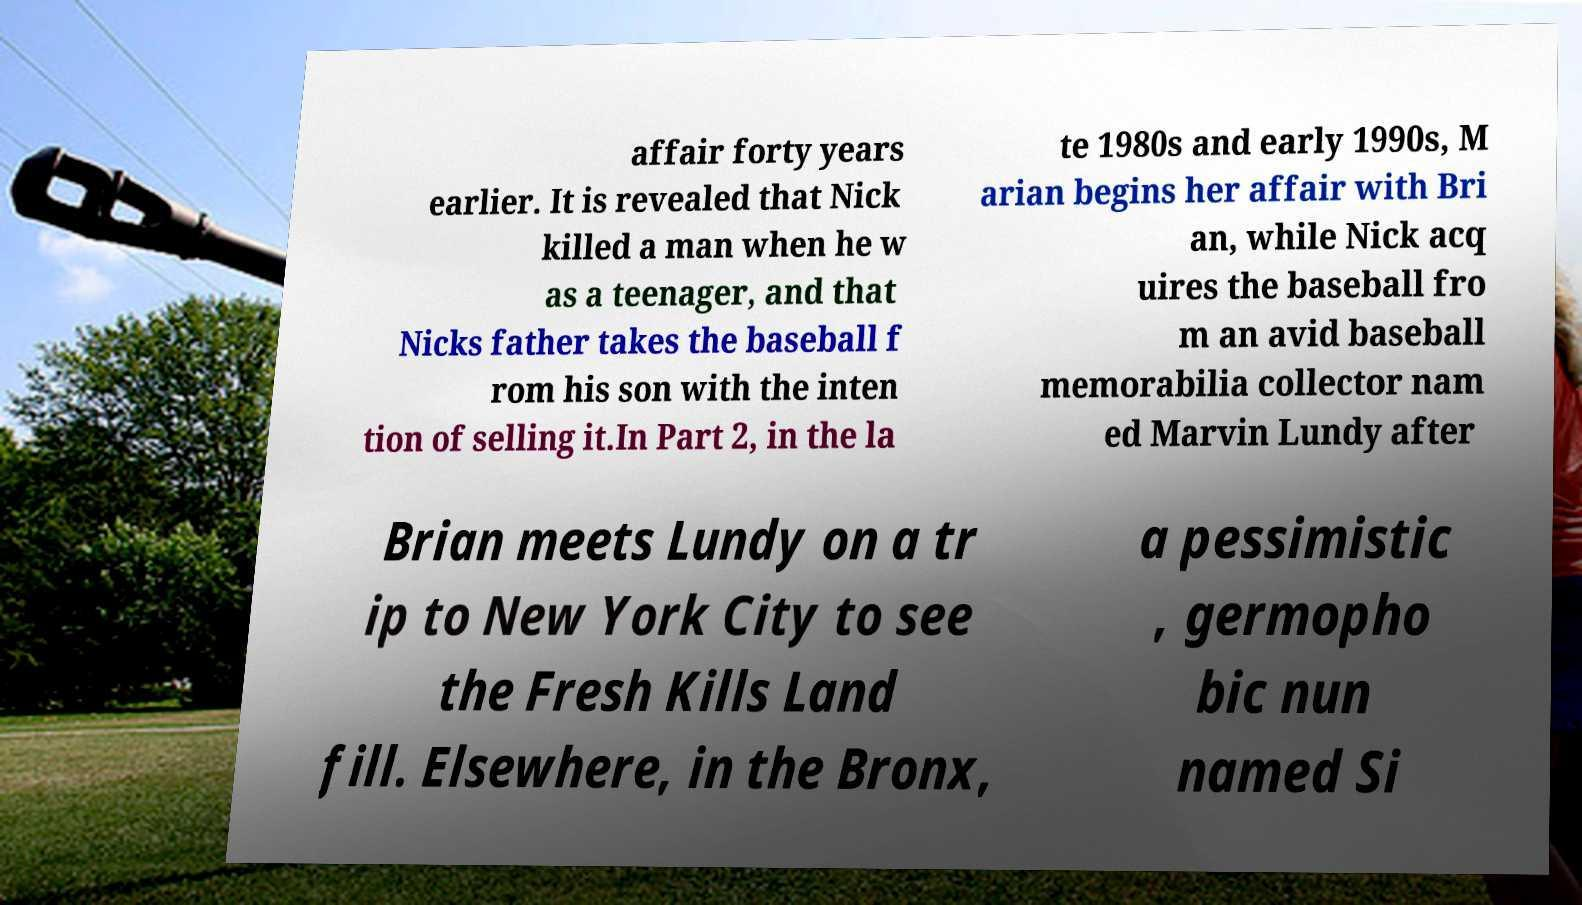Can you read and provide the text displayed in the image?This photo seems to have some interesting text. Can you extract and type it out for me? affair forty years earlier. It is revealed that Nick killed a man when he w as a teenager, and that Nicks father takes the baseball f rom his son with the inten tion of selling it.In Part 2, in the la te 1980s and early 1990s, M arian begins her affair with Bri an, while Nick acq uires the baseball fro m an avid baseball memorabilia collector nam ed Marvin Lundy after Brian meets Lundy on a tr ip to New York City to see the Fresh Kills Land fill. Elsewhere, in the Bronx, a pessimistic , germopho bic nun named Si 